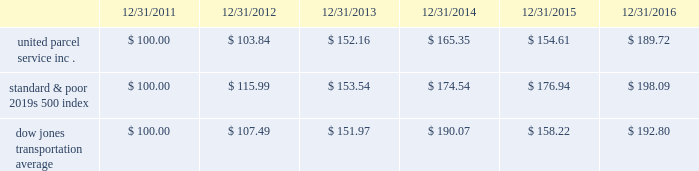Shareowner return performance graph the following performance graph and related information shall not be deemed 201csoliciting material 201d or to be 201cfiled 201d with the sec , nor shall such information be incorporated by reference into any future filing under the securities act of 1933 or securities exchange act of 1934 , each as amended , except to the extent that the company specifically incorporates such information by reference into such filing .
The following graph shows a five year comparison of cumulative total shareowners 2019 returns for our class b common stock , the standard & poor 2019s 500 index and the dow jones transportation average .
The comparison of the total cumulative return on investment , which is the change in the quarterly stock price plus reinvested dividends for each of the quarterly periods , assumes that $ 100 was invested on december 31 , 2011 in the standard & poor 2019s 500 index , the dow jones transportation average and our class b common stock. .

For the five year period ending 12/31/2016 what was the difference in total performance between united parcel service inc . and the dow jones transportation average? 
Computations: ((189.72 - 100) - (192.80 - 100))
Answer: -3.08. 